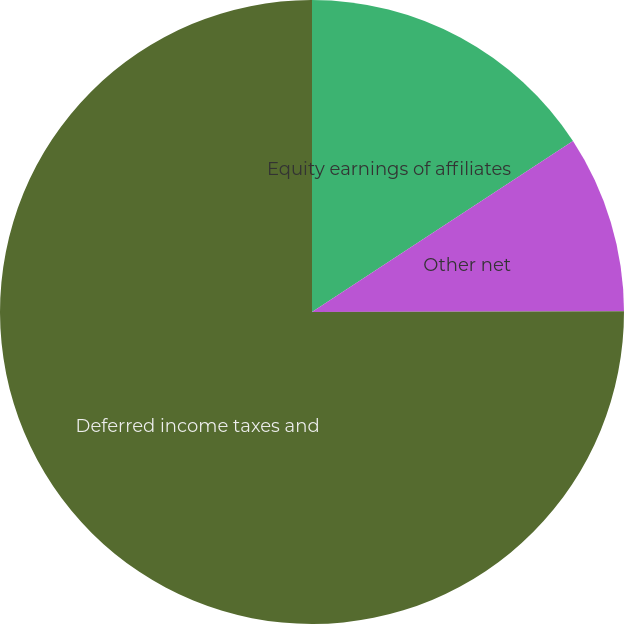Convert chart. <chart><loc_0><loc_0><loc_500><loc_500><pie_chart><fcel>Equity earnings of affiliates<fcel>Other net<fcel>Deferred income taxes and<nl><fcel>15.77%<fcel>9.19%<fcel>75.04%<nl></chart> 